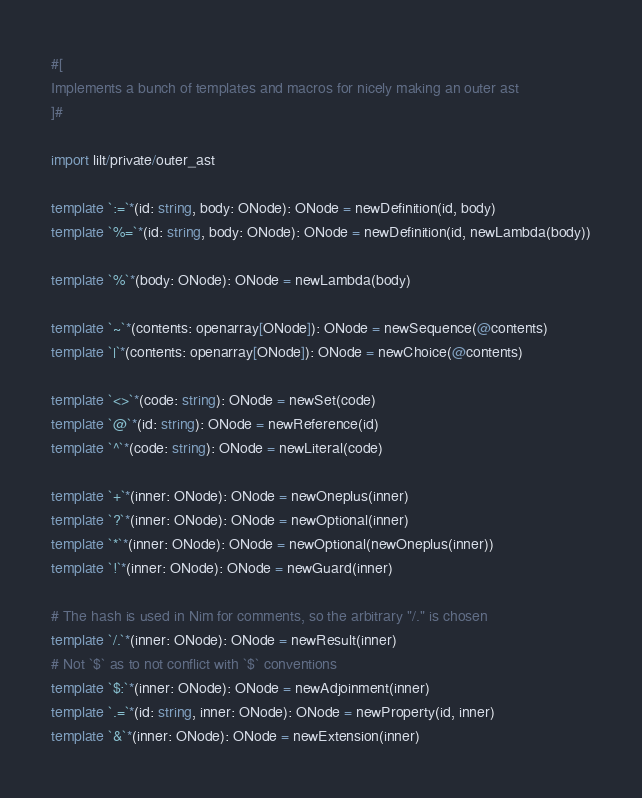<code> <loc_0><loc_0><loc_500><loc_500><_Nim_>
#[
Implements a bunch of templates and macros for nicely making an outer ast
]#

import lilt/private/outer_ast

template `:=`*(id: string, body: ONode): ONode = newDefinition(id, body)
template `%=`*(id: string, body: ONode): ONode = newDefinition(id, newLambda(body))

template `%`*(body: ONode): ONode = newLambda(body)

template `~`*(contents: openarray[ONode]): ONode = newSequence(@contents)
template `|`*(contents: openarray[ONode]): ONode = newChoice(@contents)

template `<>`*(code: string): ONode = newSet(code)
template `@`*(id: string): ONode = newReference(id)
template `^`*(code: string): ONode = newLiteral(code)

template `+`*(inner: ONode): ONode = newOneplus(inner)
template `?`*(inner: ONode): ONode = newOptional(inner)
template `*`*(inner: ONode): ONode = newOptional(newOneplus(inner))
template `!`*(inner: ONode): ONode = newGuard(inner)

# The hash is used in Nim for comments, so the arbitrary "/." is chosen
template `/.`*(inner: ONode): ONode = newResult(inner)
# Not `$` as to not conflict with `$` conventions
template `$:`*(inner: ONode): ONode = newAdjoinment(inner)
template `.=`*(id: string, inner: ONode): ONode = newProperty(id, inner)
template `&`*(inner: ONode): ONode = newExtension(inner)
</code> 